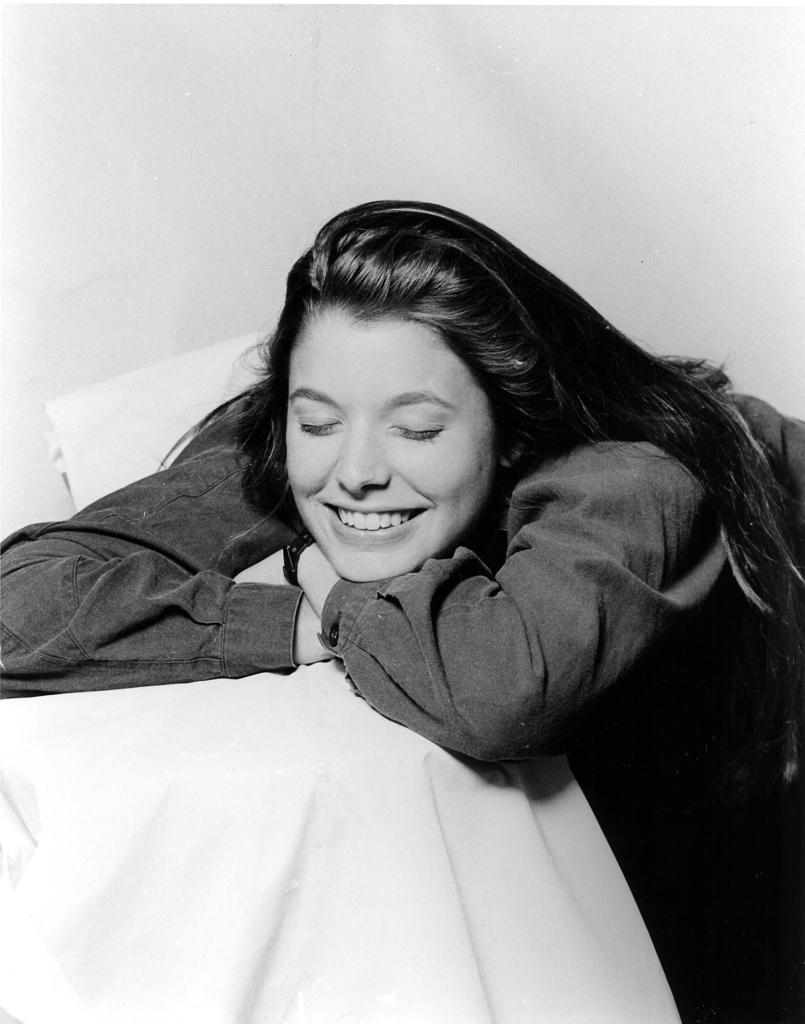What is the color scheme of the image? The image is black and white. Who or what is the main subject in the image? There is a girl in the image. What is the girl doing in the image? The girl is laying on a table. What is the girl's position on the table? The girl has her hands on the table. What type of scent can be detected from the girl in the image? There is no mention of a scent in the image, and it is not possible to detect a scent from a photograph. 